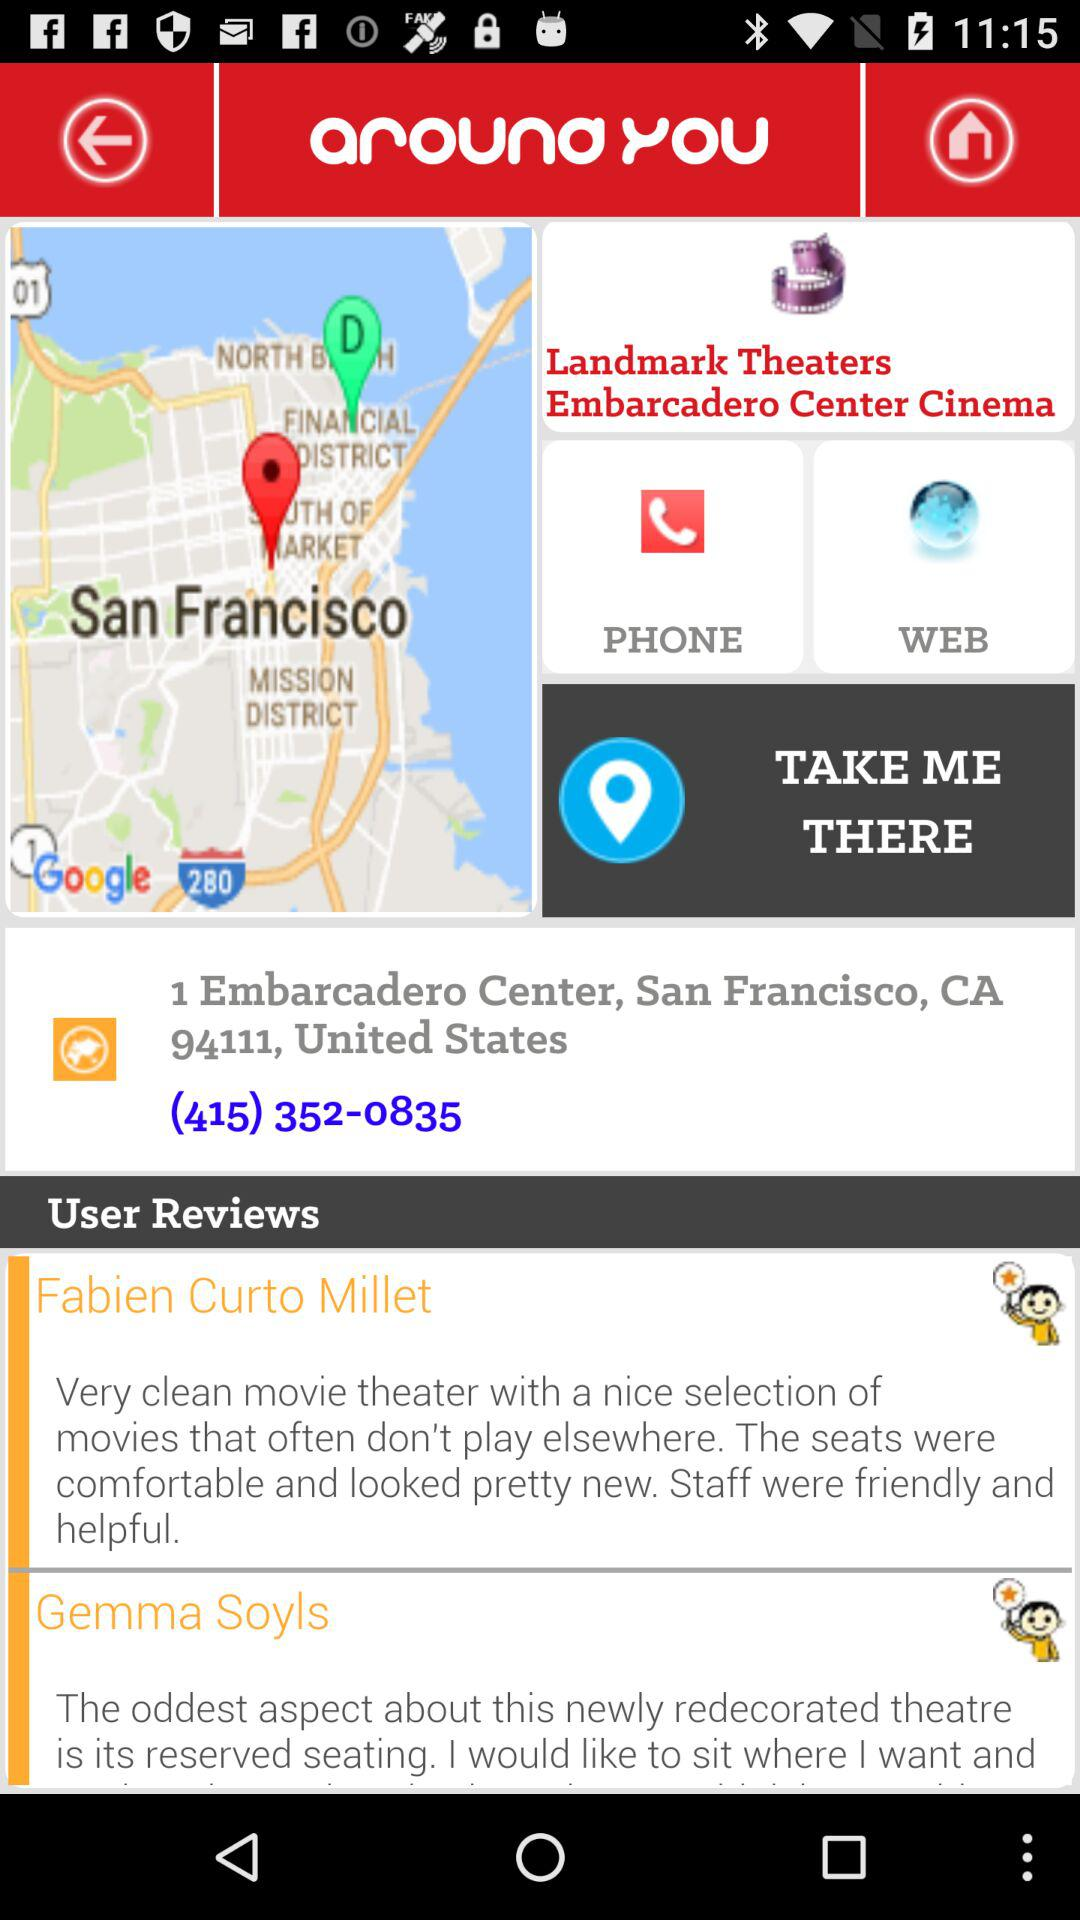How many user reviews are there on this page?
Answer the question using a single word or phrase. 2 